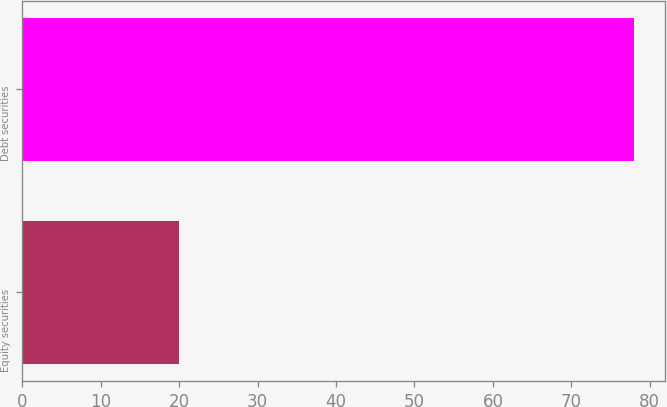Convert chart. <chart><loc_0><loc_0><loc_500><loc_500><bar_chart><fcel>Equity securities<fcel>Debt securities<nl><fcel>20<fcel>78<nl></chart> 